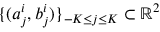<formula> <loc_0><loc_0><loc_500><loc_500>\{ ( a _ { j } ^ { i } , b _ { j } ^ { i } ) \} _ { - K \leq j \leq K } \subset \mathbb { R } ^ { 2 }</formula> 